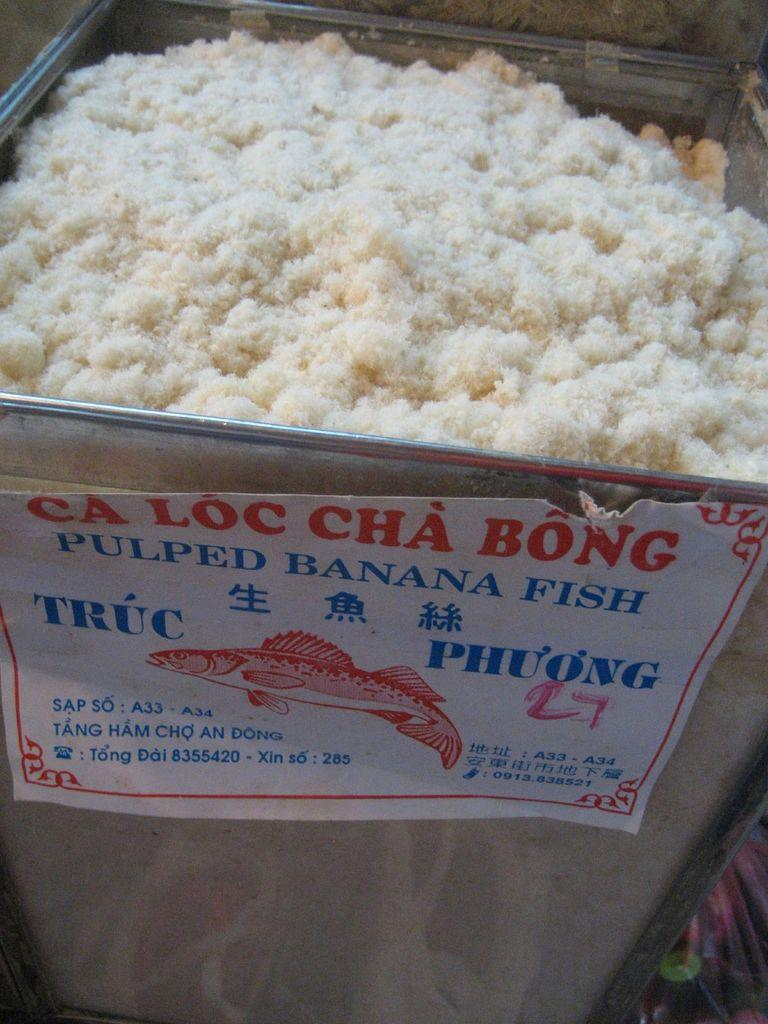What type of food item is in the big container? The facts do not specify the type of food item in the container. Can you describe the paper attached to the container? The facts only mention that there is a paper attached to the container, but no details about its appearance or content are provided. How many sheep are visible in the image? There are no sheep present in the image. Is the container being used for a game of baseball in the image? There is no indication of a baseball game or any sports-related activity in the image. 